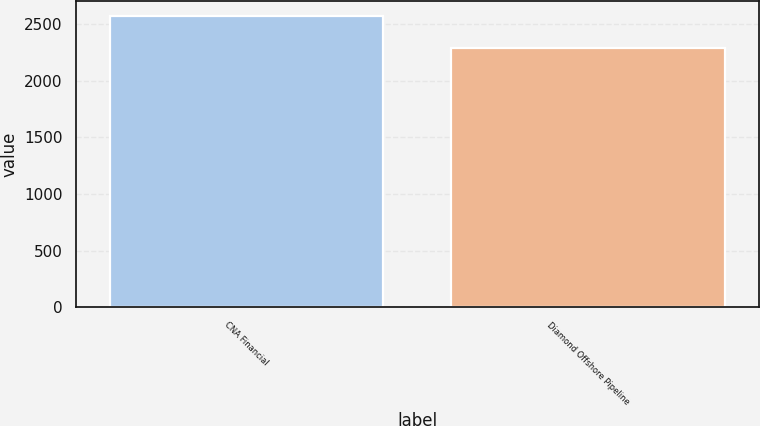<chart> <loc_0><loc_0><loc_500><loc_500><bar_chart><fcel>CNA Financial<fcel>Diamond Offshore Pipeline<nl><fcel>2577<fcel>2287<nl></chart> 